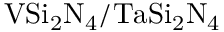Convert formula to latex. <formula><loc_0><loc_0><loc_500><loc_500>V S i _ { 2 } N _ { 4 } / T a S i _ { 2 } N _ { 4 }</formula> 